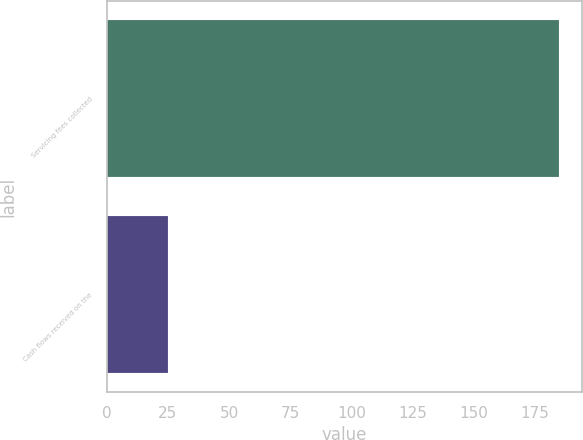<chart> <loc_0><loc_0><loc_500><loc_500><bar_chart><fcel>Servicing fees collected<fcel>Cash flows received on the<nl><fcel>185<fcel>25<nl></chart> 